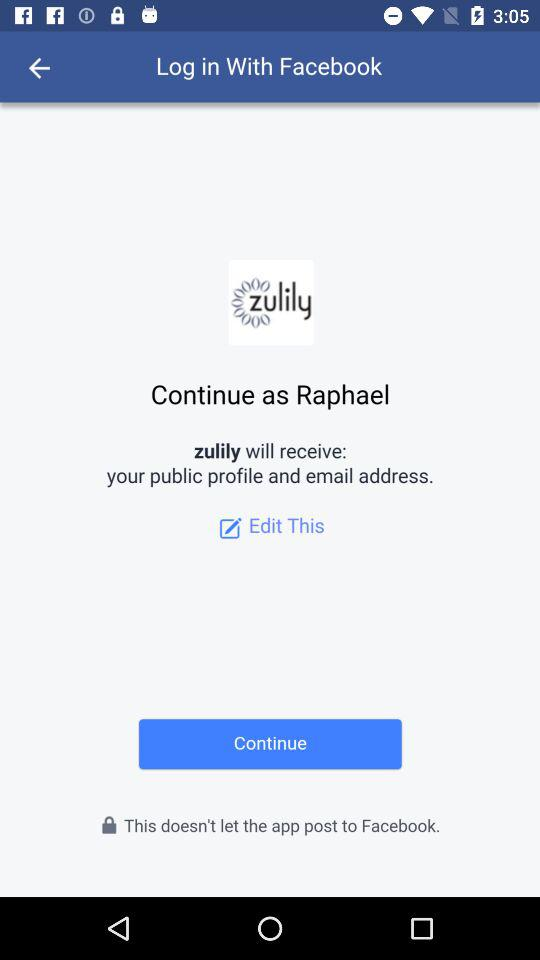What is the user name? The user name is Raphael. 